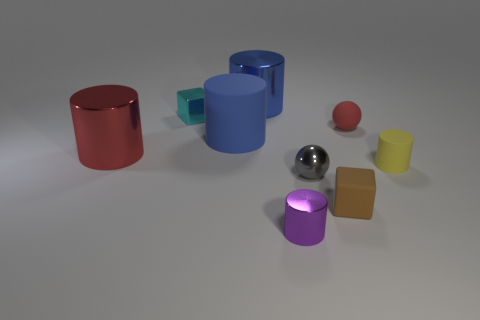Are there any big things that have the same color as the small rubber sphere?
Keep it short and to the point. Yes. What number of big objects are brown matte cubes or yellow matte things?
Your answer should be very brief. 0. There is a object that is both in front of the big rubber thing and to the left of the small metal cylinder; how big is it?
Offer a very short reply. Large. There is a red cylinder; what number of large shiny objects are behind it?
Provide a succinct answer. 1. There is a object that is both behind the yellow object and on the right side of the big blue metal thing; what shape is it?
Your response must be concise. Sphere. What material is the large cylinder that is the same color as the large rubber object?
Offer a terse response. Metal. How many cylinders are big red shiny things or purple objects?
Offer a very short reply. 2. What size is the object that is the same color as the rubber ball?
Your answer should be very brief. Large. Is the number of small purple things behind the small cyan cube less than the number of brown spheres?
Provide a short and direct response. No. There is a tiny object that is to the right of the tiny purple cylinder and to the left of the tiny brown rubber object; what is its color?
Offer a very short reply. Gray. 